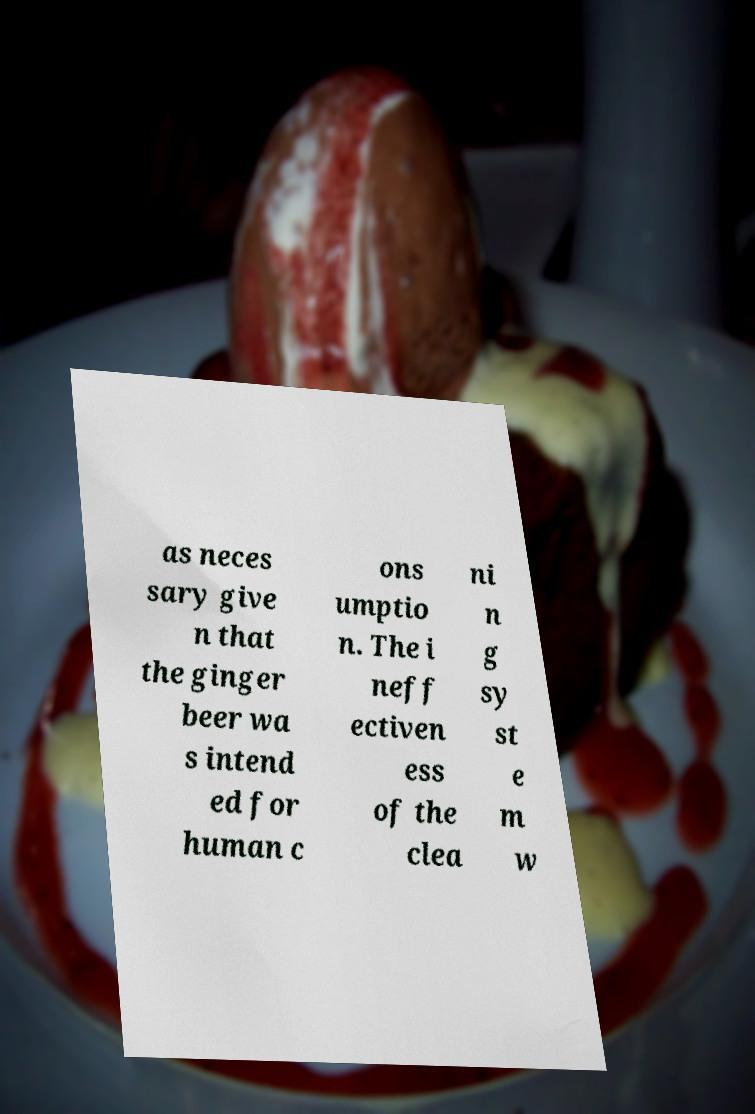Can you accurately transcribe the text from the provided image for me? as neces sary give n that the ginger beer wa s intend ed for human c ons umptio n. The i neff ectiven ess of the clea ni n g sy st e m w 